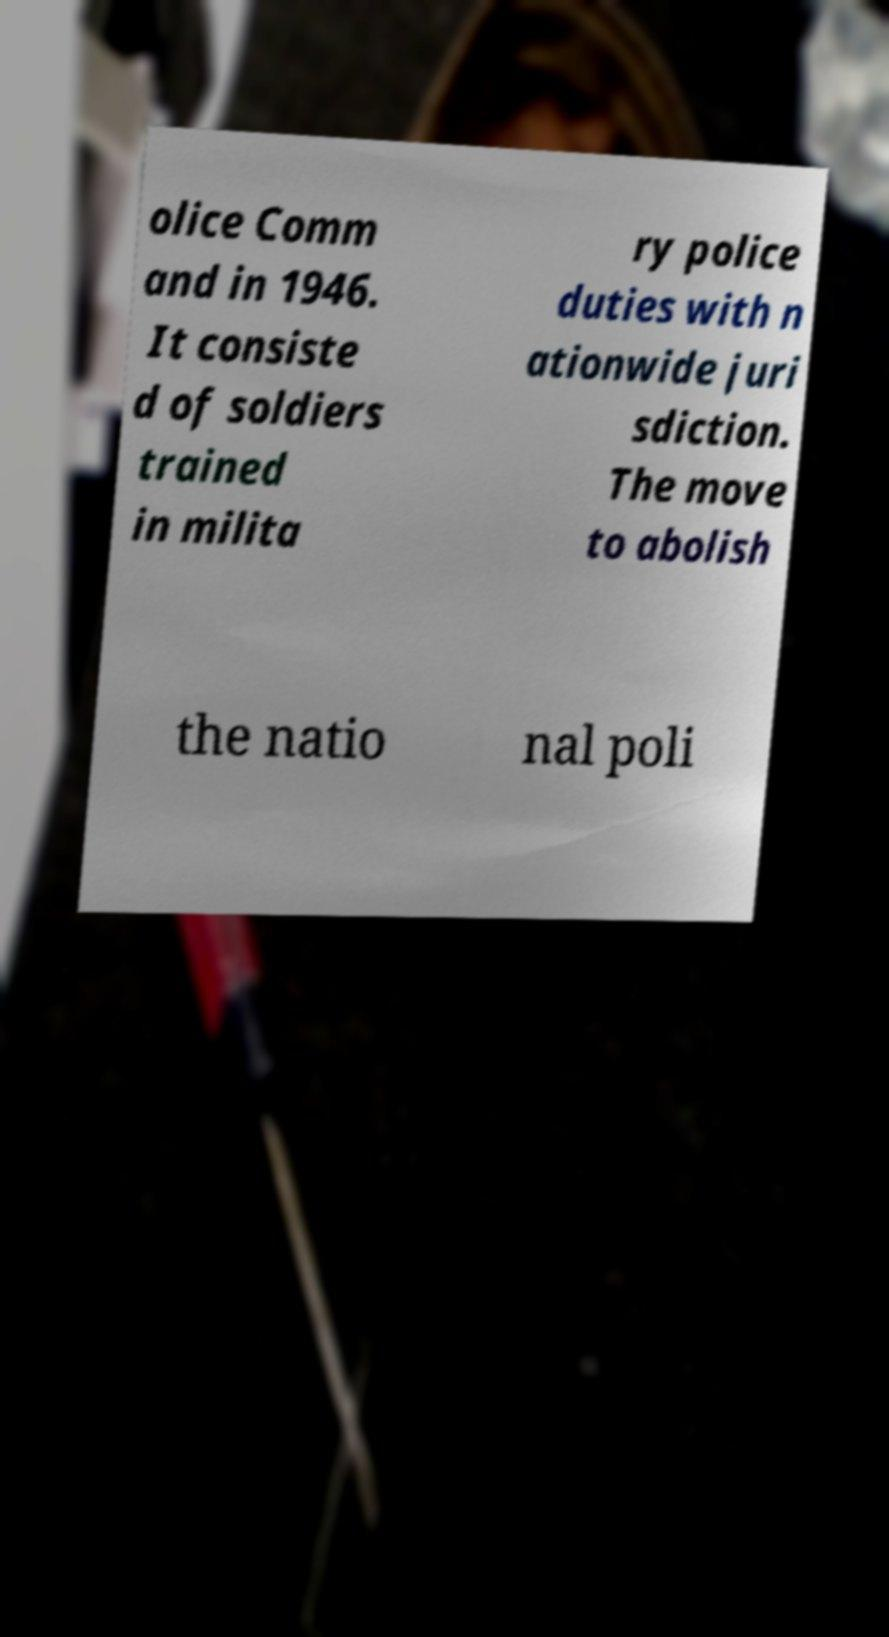Could you extract and type out the text from this image? olice Comm and in 1946. It consiste d of soldiers trained in milita ry police duties with n ationwide juri sdiction. The move to abolish the natio nal poli 